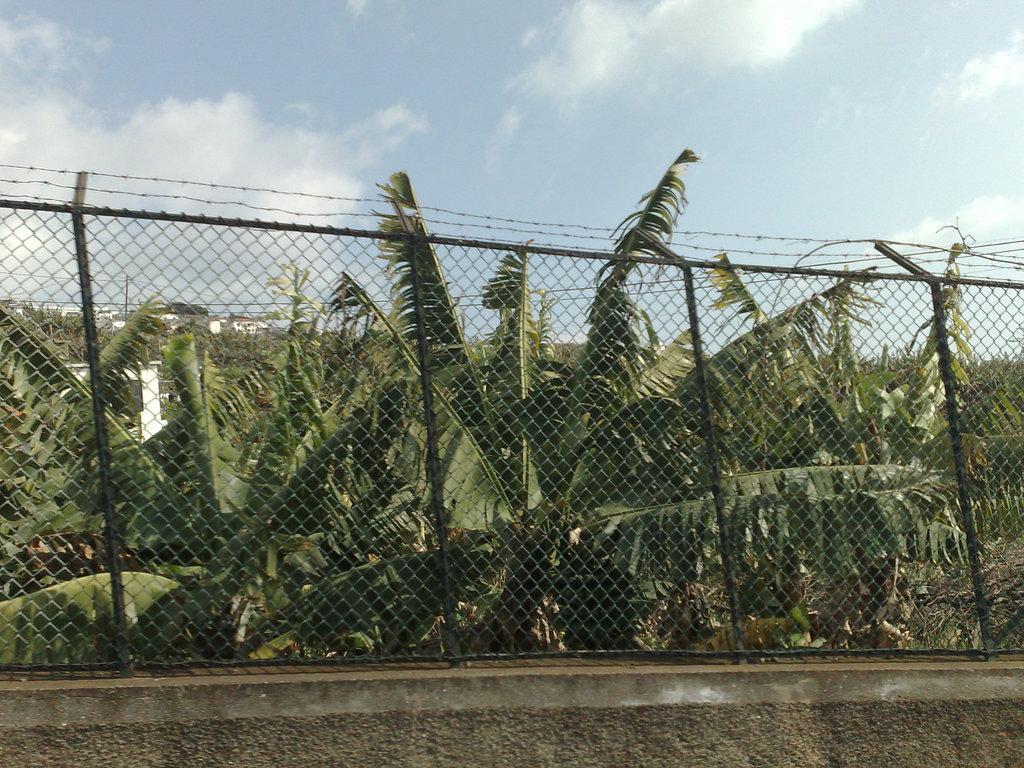How would you summarize this image in a sentence or two? In the center of the image there is a fence and there are trees. In the background there are sheds and sky. At the bottom there is a wall. 